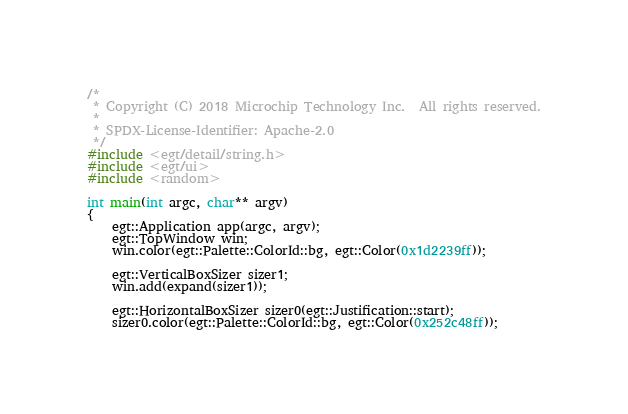Convert code to text. <code><loc_0><loc_0><loc_500><loc_500><_C++_>/*
 * Copyright (C) 2018 Microchip Technology Inc.  All rights reserved.
 *
 * SPDX-License-Identifier: Apache-2.0
 */
#include <egt/detail/string.h>
#include <egt/ui>
#include <random>

int main(int argc, char** argv)
{
    egt::Application app(argc, argv);
    egt::TopWindow win;
    win.color(egt::Palette::ColorId::bg, egt::Color(0x1d2239ff));

    egt::VerticalBoxSizer sizer1;
    win.add(expand(sizer1));

    egt::HorizontalBoxSizer sizer0(egt::Justification::start);
    sizer0.color(egt::Palette::ColorId::bg, egt::Color(0x252c48ff));</code> 